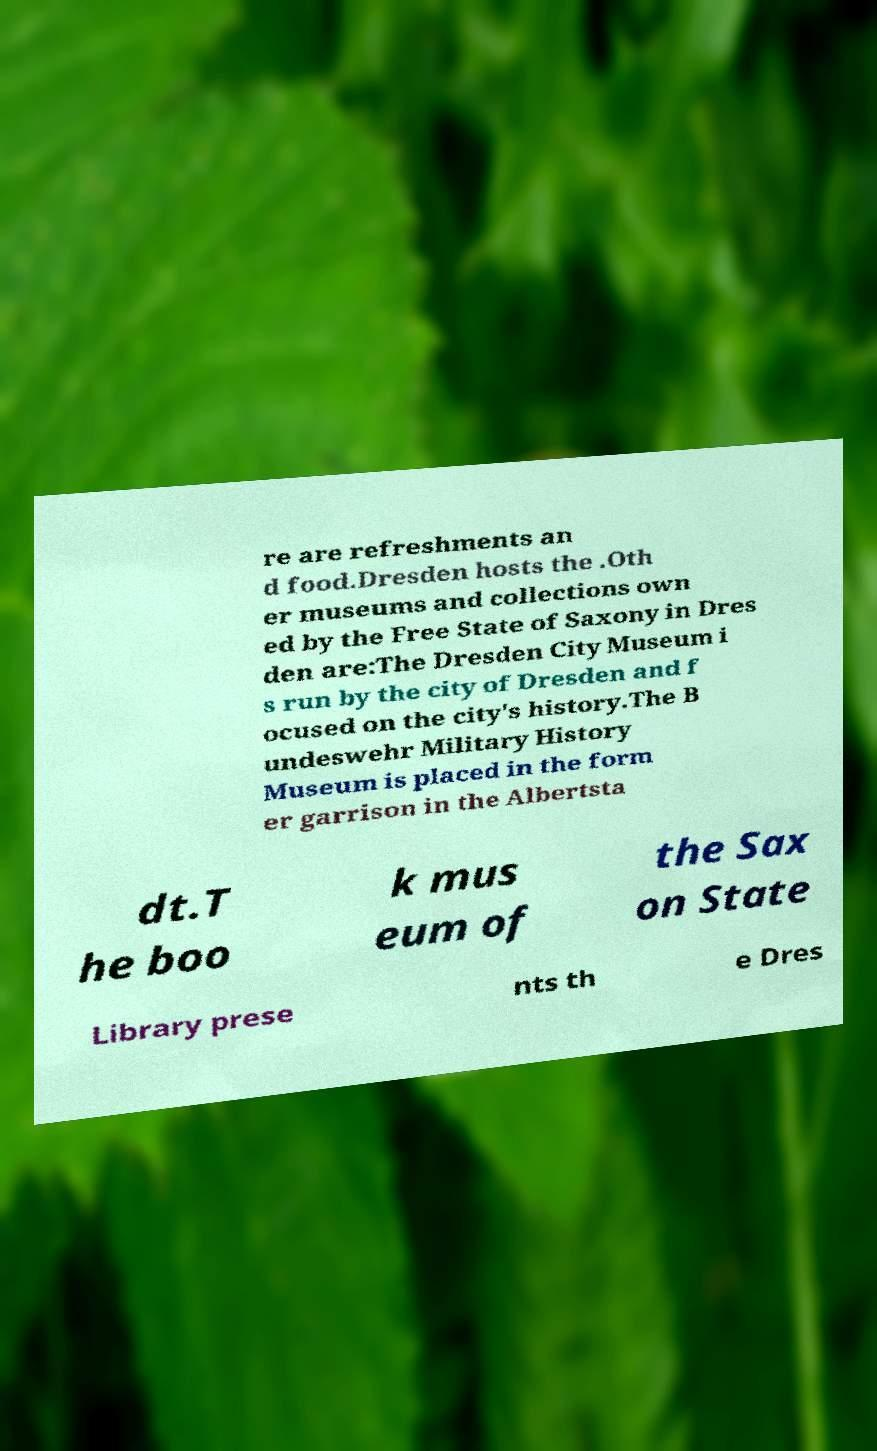Please identify and transcribe the text found in this image. re are refreshments an d food.Dresden hosts the .Oth er museums and collections own ed by the Free State of Saxony in Dres den are:The Dresden City Museum i s run by the city of Dresden and f ocused on the city's history.The B undeswehr Military History Museum is placed in the form er garrison in the Albertsta dt.T he boo k mus eum of the Sax on State Library prese nts th e Dres 